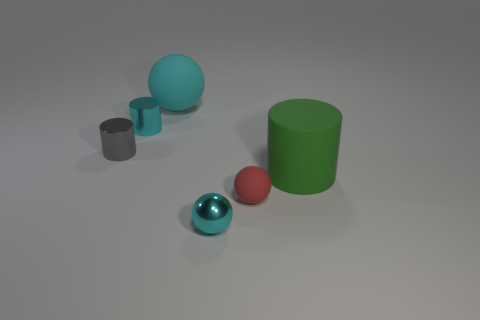Add 4 blue rubber balls. How many objects exist? 10 Add 2 gray cylinders. How many gray cylinders are left? 3 Add 3 big shiny things. How many big shiny things exist? 3 Subtract 1 cyan cylinders. How many objects are left? 5 Subtract all big green things. Subtract all purple cylinders. How many objects are left? 5 